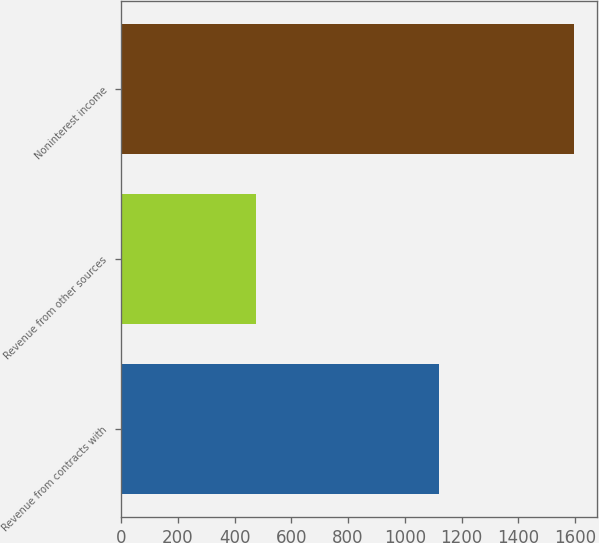<chart> <loc_0><loc_0><loc_500><loc_500><bar_chart><fcel>Revenue from contracts with<fcel>Revenue from other sources<fcel>Noninterest income<nl><fcel>1119<fcel>477<fcel>1596<nl></chart> 